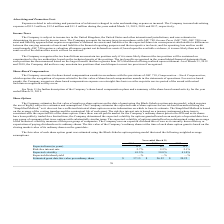According to Mimecast Limited's financial document, Which model is used to estimate the fair value of employee share option? Black-Scholes option-pricing model. The document states: "oyee share options on the date of grant using the Black-Scholes option-pricing model, which requires..." Also, What is the risk free rate based on? treasury instrument whose term is consistent with the expected life of the share option.. The document states: "h grant. The risk-free interest rate is based on a treasury instrument whose term is consistent with the expected life of the share option. Since ther..." Also, What was the Expected term (in years) in 2019, 2018 and 2017 respectively? The document contains multiple relevant values: 6.1, 6.1, 6.1. From the document: "Expected term (in years) 6.1 6.1 6.1..." Also, can you calculate: What was the change in the Risk-free interest rate from 2018 to 2019? Based on the calculation: 2.7 - 2.2, the result is 0.5 (percentage). This is based on the information: "Risk-free interest rate 2.7% 2.2% 2.1% Risk-free interest rate 2.7% 2.2% 2.1%..." The key data points involved are: 2.2, 2.7. Also, can you calculate: What was the average Expected volatility between 2017-2019? To answer this question, I need to perform calculations using the financial data. The calculation is: (41.5 + 39.8 + 41.0) / 3, which equals 40.77 (percentage). This is based on the information: "Expected volatility 41.5% 39.8% 41.0% Expected volatility 41.5% 39.8% 41.0% Expected volatility 41.5% 39.8% 41.0%..." The key data points involved are: 39.8, 41.0, 41.5. Additionally, In which year was Estimated grant date fair value per ordinary share less than 30? The document shows two values: 2018 and 2017. Locate and analyze estimated grant date fair value per ordinary share in row 7. From the document: "2019 2018 2017 2019 2018 2017..." 